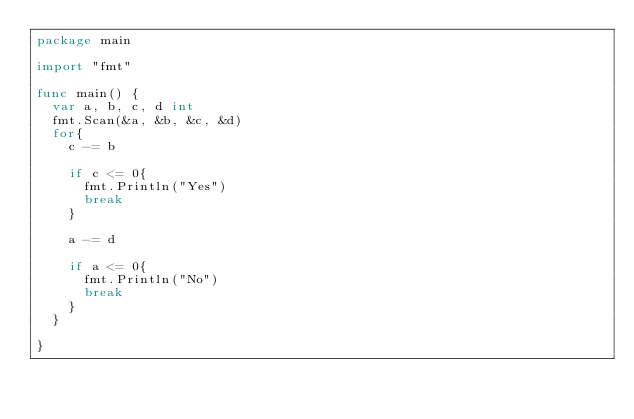<code> <loc_0><loc_0><loc_500><loc_500><_Go_>package main

import "fmt"

func main() {
	var a, b, c, d int
	fmt.Scan(&a, &b, &c, &d)
	for{
		c -= b

		if c <= 0{
			fmt.Println("Yes")
			break
		}

		a -= d

		if a <= 0{
			fmt.Println("No")
			break
		}
	}

}</code> 